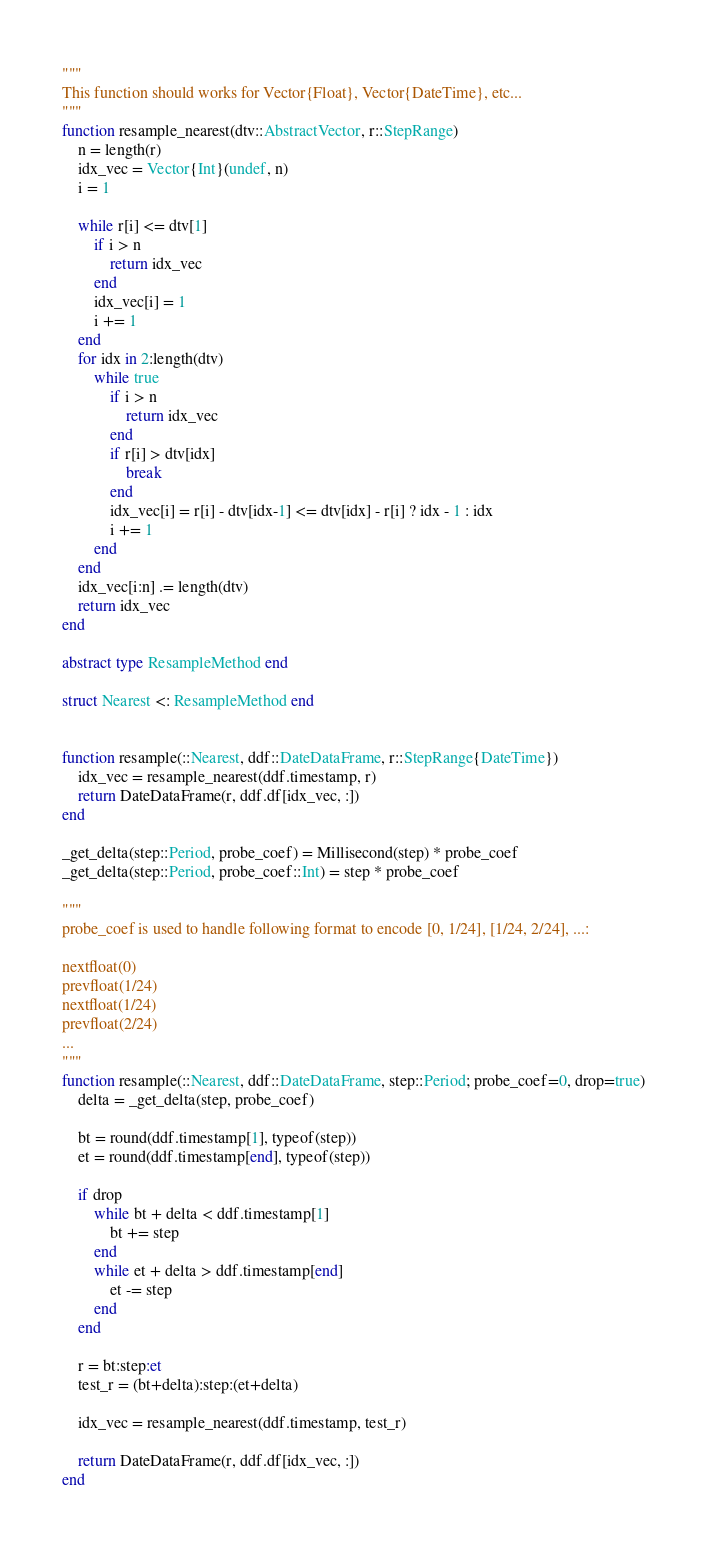Convert code to text. <code><loc_0><loc_0><loc_500><loc_500><_Julia_>
"""
This function should works for Vector{Float}, Vector{DateTime}, etc...
"""
function resample_nearest(dtv::AbstractVector, r::StepRange)
    n = length(r)
    idx_vec = Vector{Int}(undef, n)
    i = 1
    
    while r[i] <= dtv[1]
        if i > n
            return idx_vec
        end
        idx_vec[i] = 1
        i += 1
    end
    for idx in 2:length(dtv)
        while true
            if i > n
                return idx_vec
            end
            if r[i] > dtv[idx]
                break
            end  
            idx_vec[i] = r[i] - dtv[idx-1] <= dtv[idx] - r[i] ? idx - 1 : idx
            i += 1
        end
    end
    idx_vec[i:n] .= length(dtv)
    return idx_vec
end

abstract type ResampleMethod end

struct Nearest <: ResampleMethod end


function resample(::Nearest, ddf::DateDataFrame, r::StepRange{DateTime})
    idx_vec = resample_nearest(ddf.timestamp, r)
    return DateDataFrame(r, ddf.df[idx_vec, :])
end

_get_delta(step::Period, probe_coef) = Millisecond(step) * probe_coef
_get_delta(step::Period, probe_coef::Int) = step * probe_coef

"""
probe_coef is used to handle following format to encode [0, 1/24], [1/24, 2/24], ...:

nextfloat(0)
prevfloat(1/24)
nextfloat(1/24)
prevfloat(2/24)
...
"""
function resample(::Nearest, ddf::DateDataFrame, step::Period; probe_coef=0, drop=true)
    delta = _get_delta(step, probe_coef)

    bt = round(ddf.timestamp[1], typeof(step))
    et = round(ddf.timestamp[end], typeof(step))

    if drop
        while bt + delta < ddf.timestamp[1]
            bt += step
        end
        while et + delta > ddf.timestamp[end]
            et -= step
        end
    end

    r = bt:step:et 
    test_r = (bt+delta):step:(et+delta)

    idx_vec = resample_nearest(ddf.timestamp, test_r)
    
    return DateDataFrame(r, ddf.df[idx_vec, :])
end
</code> 